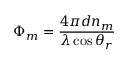Convert formula to latex. <formula><loc_0><loc_0><loc_500><loc_500>\Phi _ { m } = \frac { 4 \pi d n _ { m } } { \lambda \cos \theta _ { r } }</formula> 